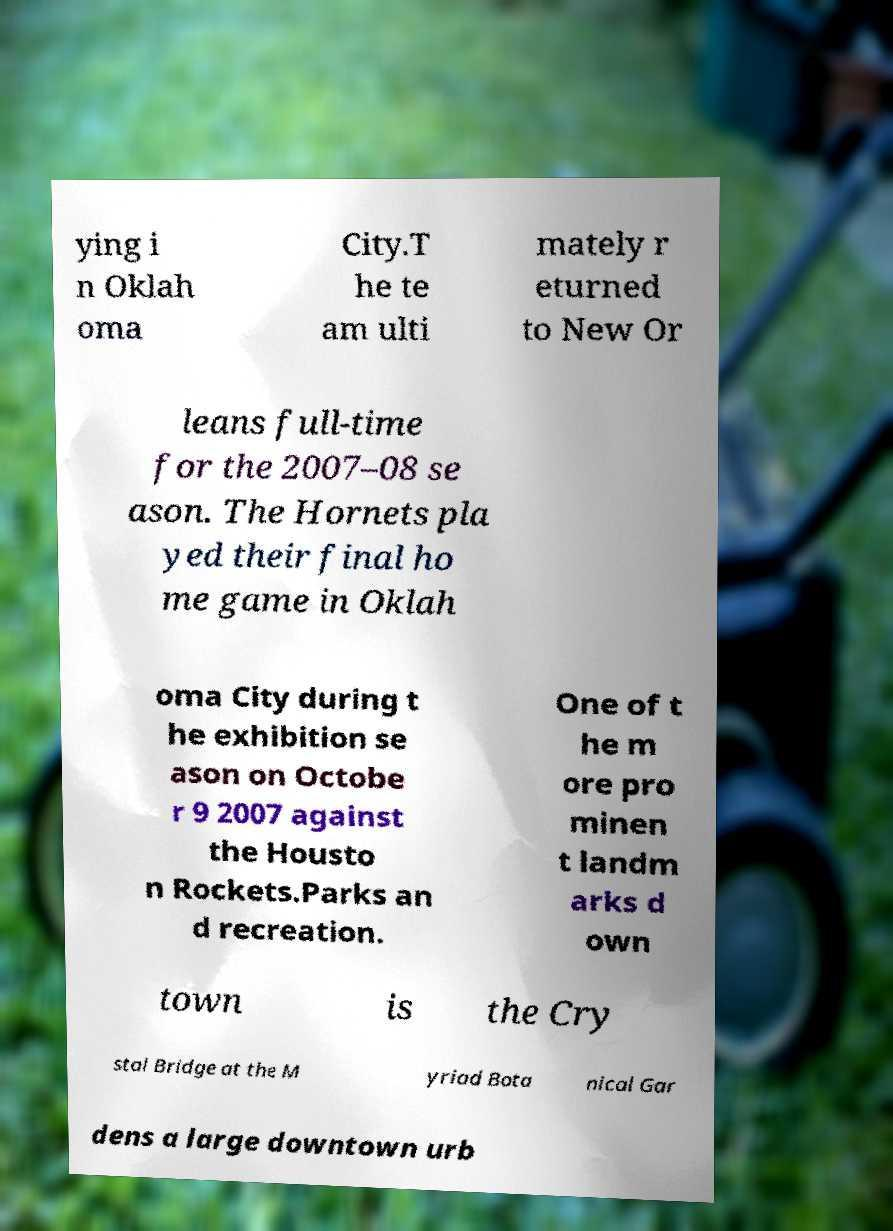Can you accurately transcribe the text from the provided image for me? ying i n Oklah oma City.T he te am ulti mately r eturned to New Or leans full-time for the 2007–08 se ason. The Hornets pla yed their final ho me game in Oklah oma City during t he exhibition se ason on Octobe r 9 2007 against the Housto n Rockets.Parks an d recreation. One of t he m ore pro minen t landm arks d own town is the Cry stal Bridge at the M yriad Bota nical Gar dens a large downtown urb 